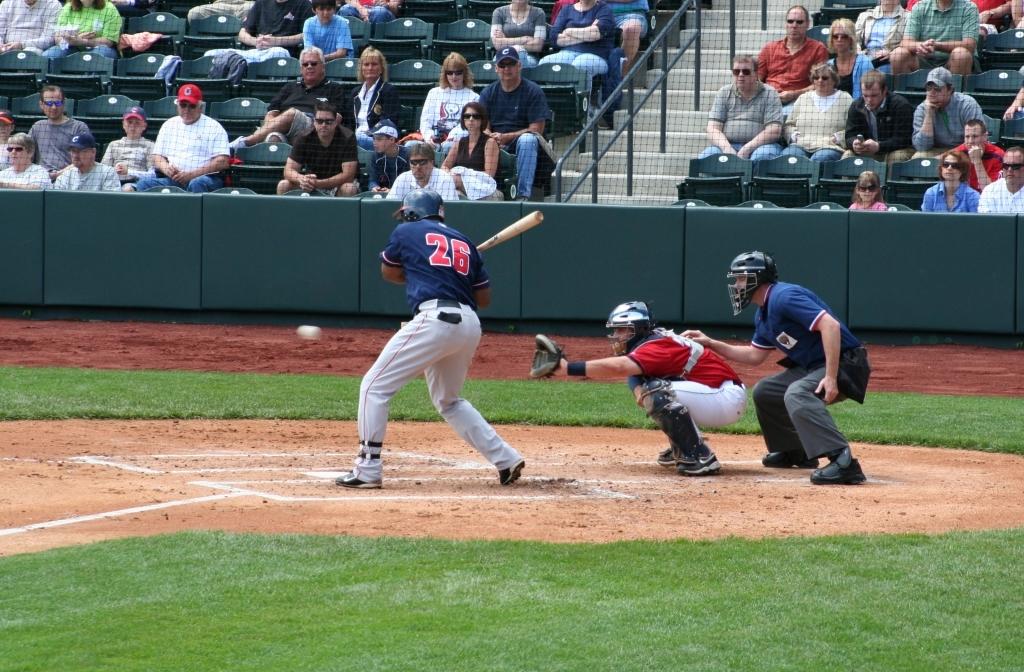What number jersey does the current batter wear?
Your answer should be compact. 26. 